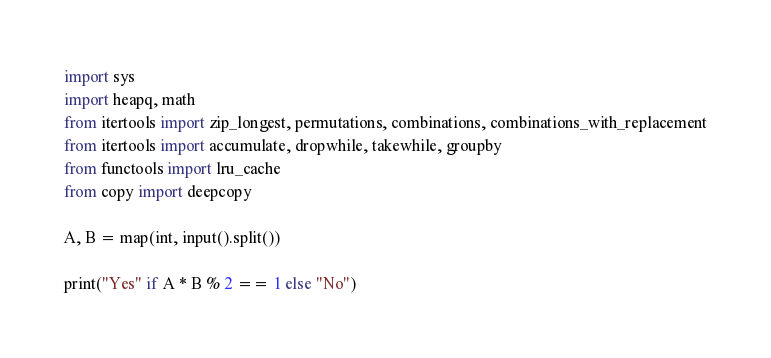<code> <loc_0><loc_0><loc_500><loc_500><_Python_>import sys
import heapq, math
from itertools import zip_longest, permutations, combinations, combinations_with_replacement
from itertools import accumulate, dropwhile, takewhile, groupby
from functools import lru_cache
from copy import deepcopy

A, B = map(int, input().split())

print("Yes" if A * B % 2 == 1 else "No")</code> 